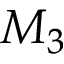Convert formula to latex. <formula><loc_0><loc_0><loc_500><loc_500>M _ { 3 }</formula> 